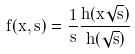Convert formula to latex. <formula><loc_0><loc_0><loc_500><loc_500>\tilde { f } ( x , s ) = \frac { 1 } { s } \frac { h ( x \sqrt { s } ) } { h ( \sqrt { s } ) }</formula> 